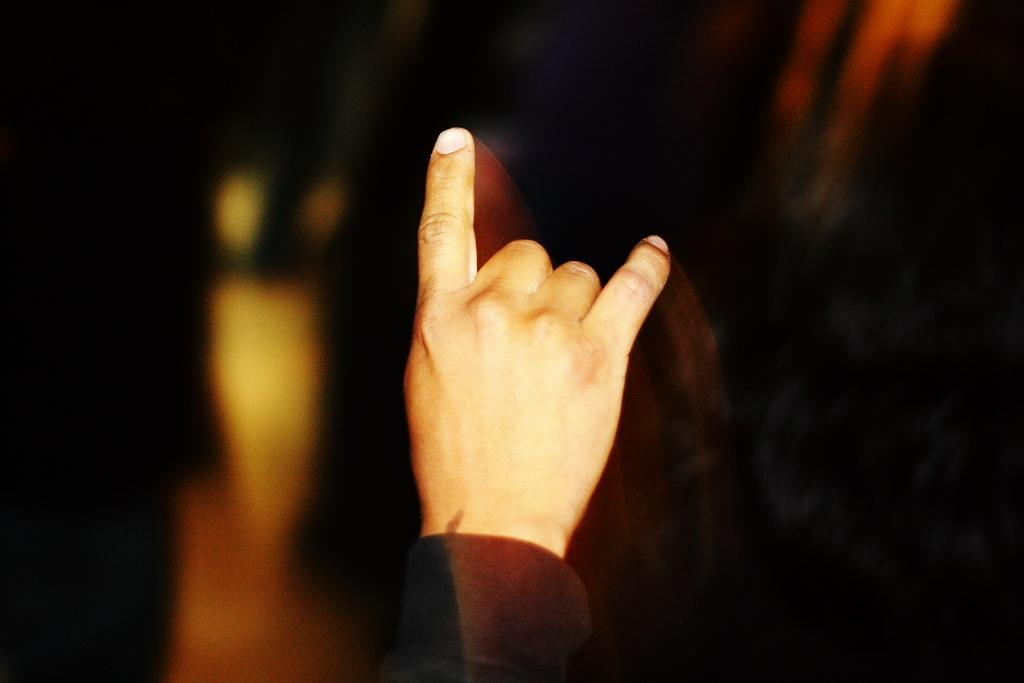What is the main subject of the image? The main subject of the image is a person's hand. What type of grass is the person's hand stretching in the image? There is no grass present in the image, and the person's hand is not stretching. 